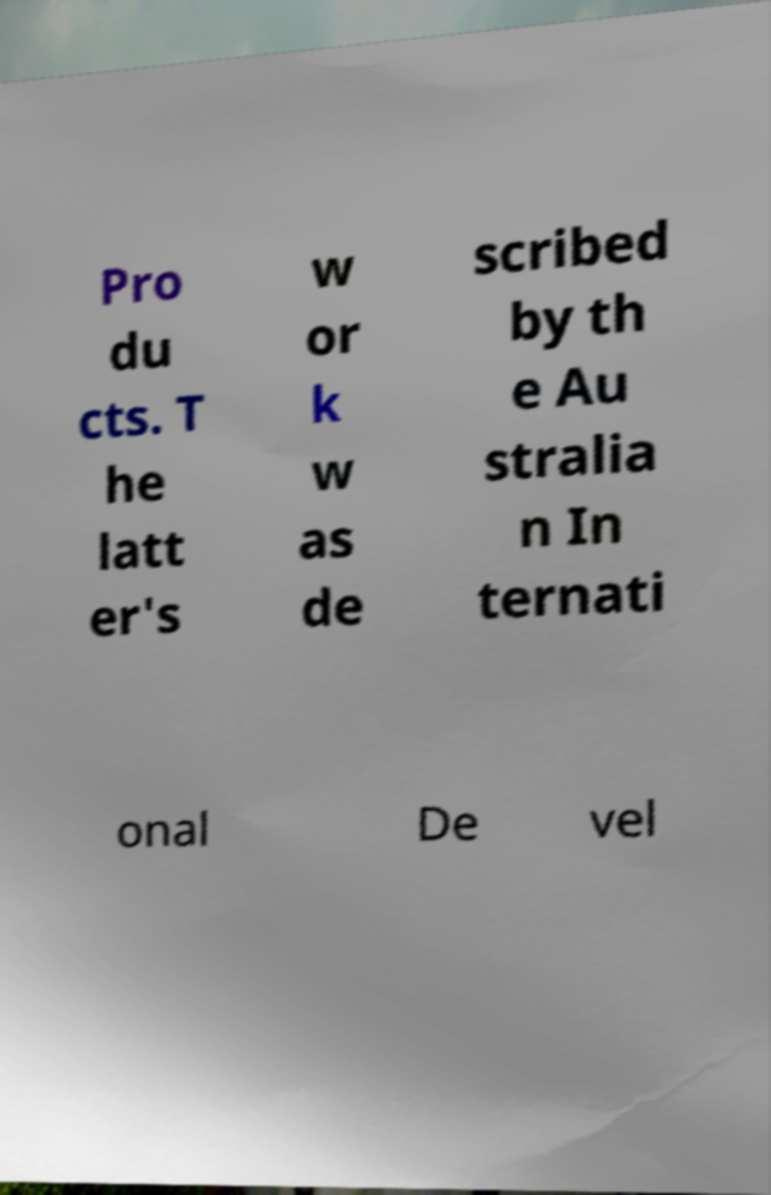Could you assist in decoding the text presented in this image and type it out clearly? Pro du cts. T he latt er's w or k w as de scribed by th e Au stralia n In ternati onal De vel 